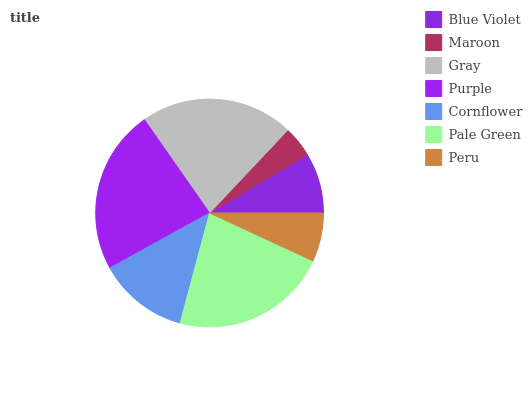Is Maroon the minimum?
Answer yes or no. Yes. Is Purple the maximum?
Answer yes or no. Yes. Is Gray the minimum?
Answer yes or no. No. Is Gray the maximum?
Answer yes or no. No. Is Gray greater than Maroon?
Answer yes or no. Yes. Is Maroon less than Gray?
Answer yes or no. Yes. Is Maroon greater than Gray?
Answer yes or no. No. Is Gray less than Maroon?
Answer yes or no. No. Is Cornflower the high median?
Answer yes or no. Yes. Is Cornflower the low median?
Answer yes or no. Yes. Is Purple the high median?
Answer yes or no. No. Is Peru the low median?
Answer yes or no. No. 